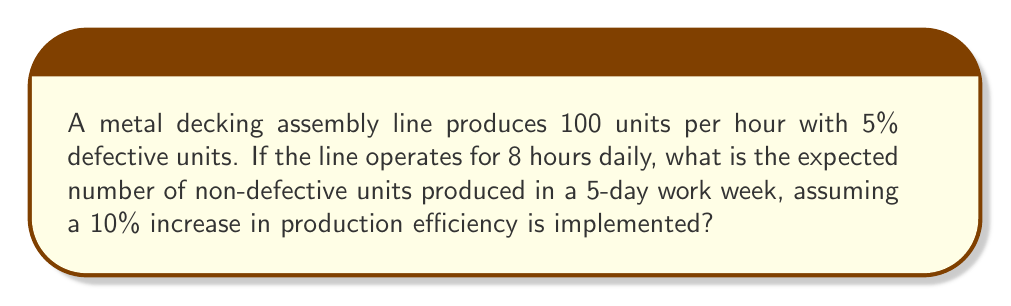Solve this math problem. Let's break this down step-by-step:

1. Calculate the initial daily production:
   $$100 \text{ units/hour} \times 8 \text{ hours} = 800 \text{ units/day}$$

2. Calculate the initial number of non-defective units per day:
   $$800 \times (1 - 0.05) = 800 \times 0.95 = 760 \text{ non-defective units/day}$$

3. Calculate the initial weekly production (5-day work week):
   $$760 \text{ units/day} \times 5 \text{ days} = 3800 \text{ non-defective units/week}$$

4. Implement the 10% increase in production efficiency:
   $$\text{New production rate} = 100 \text{ units/hour} \times 1.10 = 110 \text{ units/hour}$$

5. Calculate the new daily production:
   $$110 \text{ units/hour} \times 8 \text{ hours} = 880 \text{ units/day}$$

6. Calculate the new number of non-defective units per day:
   $$880 \times (1 - 0.05) = 880 \times 0.95 = 836 \text{ non-defective units/day}$$

7. Calculate the new weekly production (5-day work week):
   $$836 \text{ units/day} \times 5 \text{ days} = 4180 \text{ non-defective units/week}$$

Therefore, the expected number of non-defective units produced in a 5-day work week after implementing the 10% increase in production efficiency is 4180 units.
Answer: 4180 units 